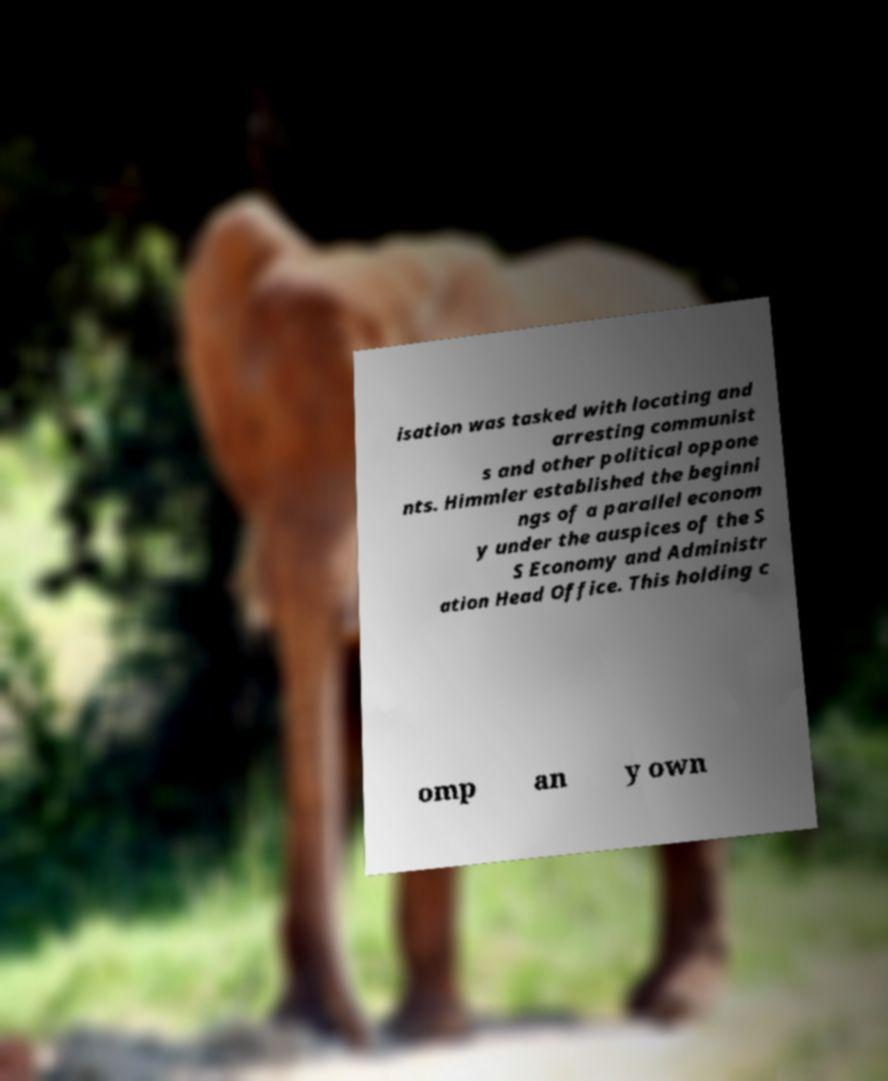Could you extract and type out the text from this image? isation was tasked with locating and arresting communist s and other political oppone nts. Himmler established the beginni ngs of a parallel econom y under the auspices of the S S Economy and Administr ation Head Office. This holding c omp an y own 